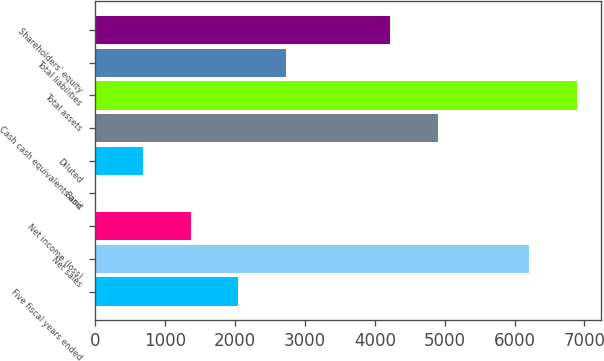Convert chart to OTSL. <chart><loc_0><loc_0><loc_500><loc_500><bar_chart><fcel>Five fiscal years ended<fcel>Net sales<fcel>Net income (loss)<fcel>Basic<fcel>Diluted<fcel>Cash cash equivalents and<fcel>Total assets<fcel>Total liabilities<fcel>Shareholders' equity<nl><fcel>2044.63<fcel>6207<fcel>1363.15<fcel>0.19<fcel>681.67<fcel>4904.48<fcel>6888.48<fcel>2726.11<fcel>4223<nl></chart> 